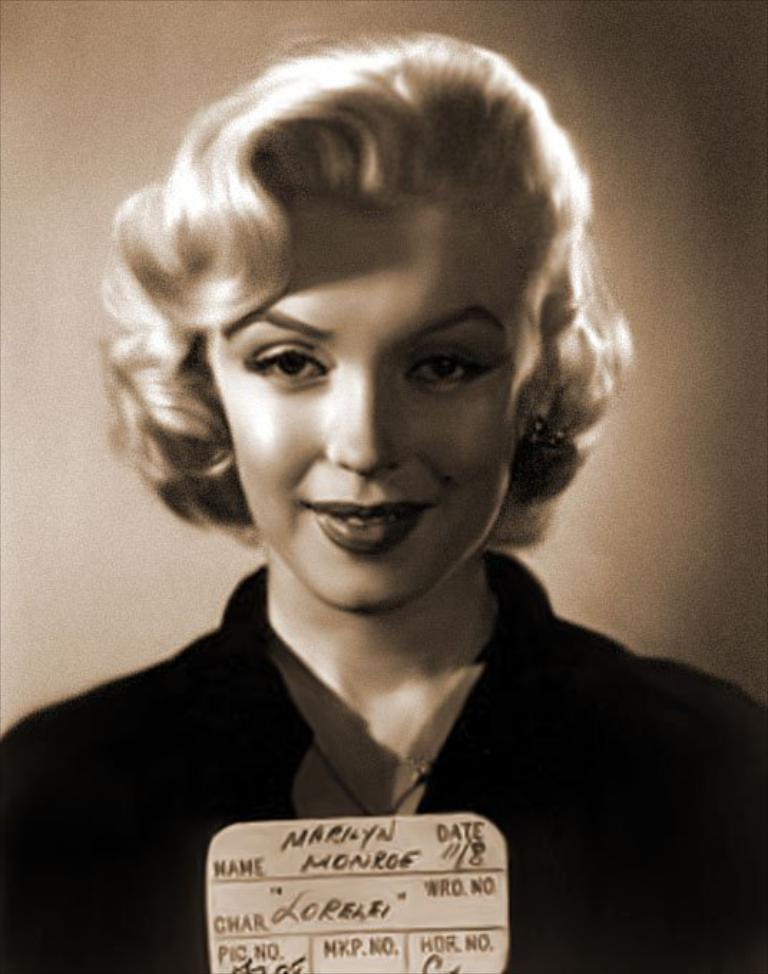Who is present in the image? There is a woman in the image. What is the woman's facial expression? The woman is smiling. What object with writing on it can be seen in the image? There is a paper with writing on it in the image. What color is the paper? The paper is brown. How would you describe the background of the image? The background of the image is dark. What type of disease is the woman suffering from in the image? There is no indication in the image that the woman is suffering from any disease. What type of cheese is present in the image? There is no cheese present in the image. 